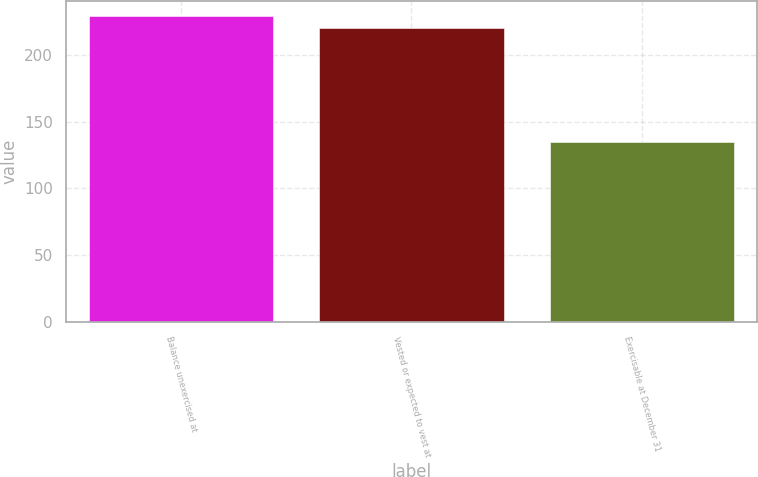Convert chart. <chart><loc_0><loc_0><loc_500><loc_500><bar_chart><fcel>Balance unexercised at<fcel>Vested or expected to vest at<fcel>Exercisable at December 31<nl><fcel>229<fcel>220<fcel>135<nl></chart> 